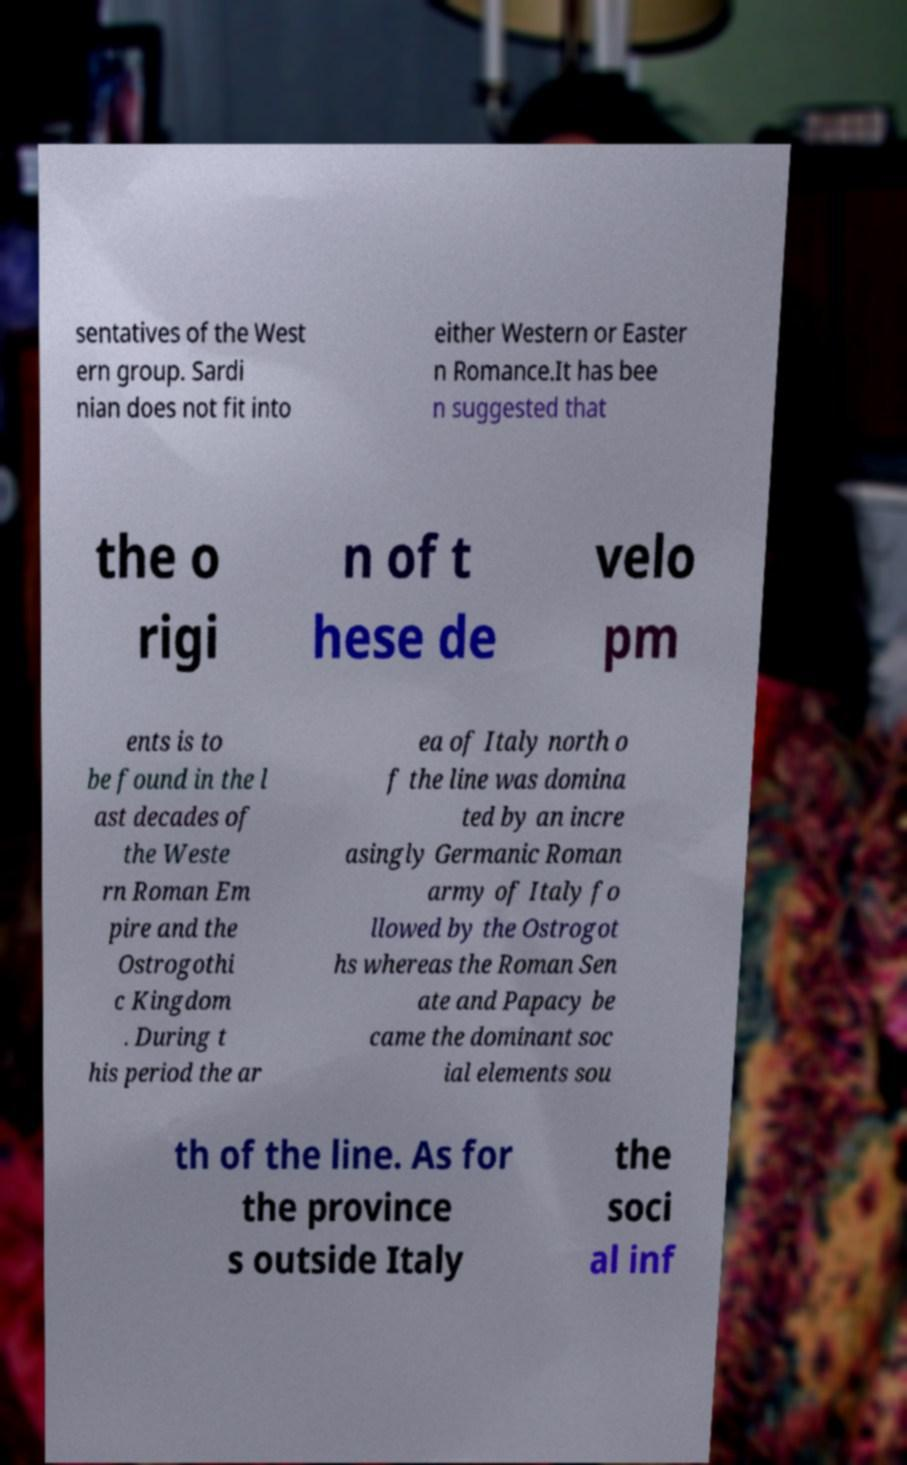There's text embedded in this image that I need extracted. Can you transcribe it verbatim? sentatives of the West ern group. Sardi nian does not fit into either Western or Easter n Romance.It has bee n suggested that the o rigi n of t hese de velo pm ents is to be found in the l ast decades of the Weste rn Roman Em pire and the Ostrogothi c Kingdom . During t his period the ar ea of Italy north o f the line was domina ted by an incre asingly Germanic Roman army of Italy fo llowed by the Ostrogot hs whereas the Roman Sen ate and Papacy be came the dominant soc ial elements sou th of the line. As for the province s outside Italy the soci al inf 